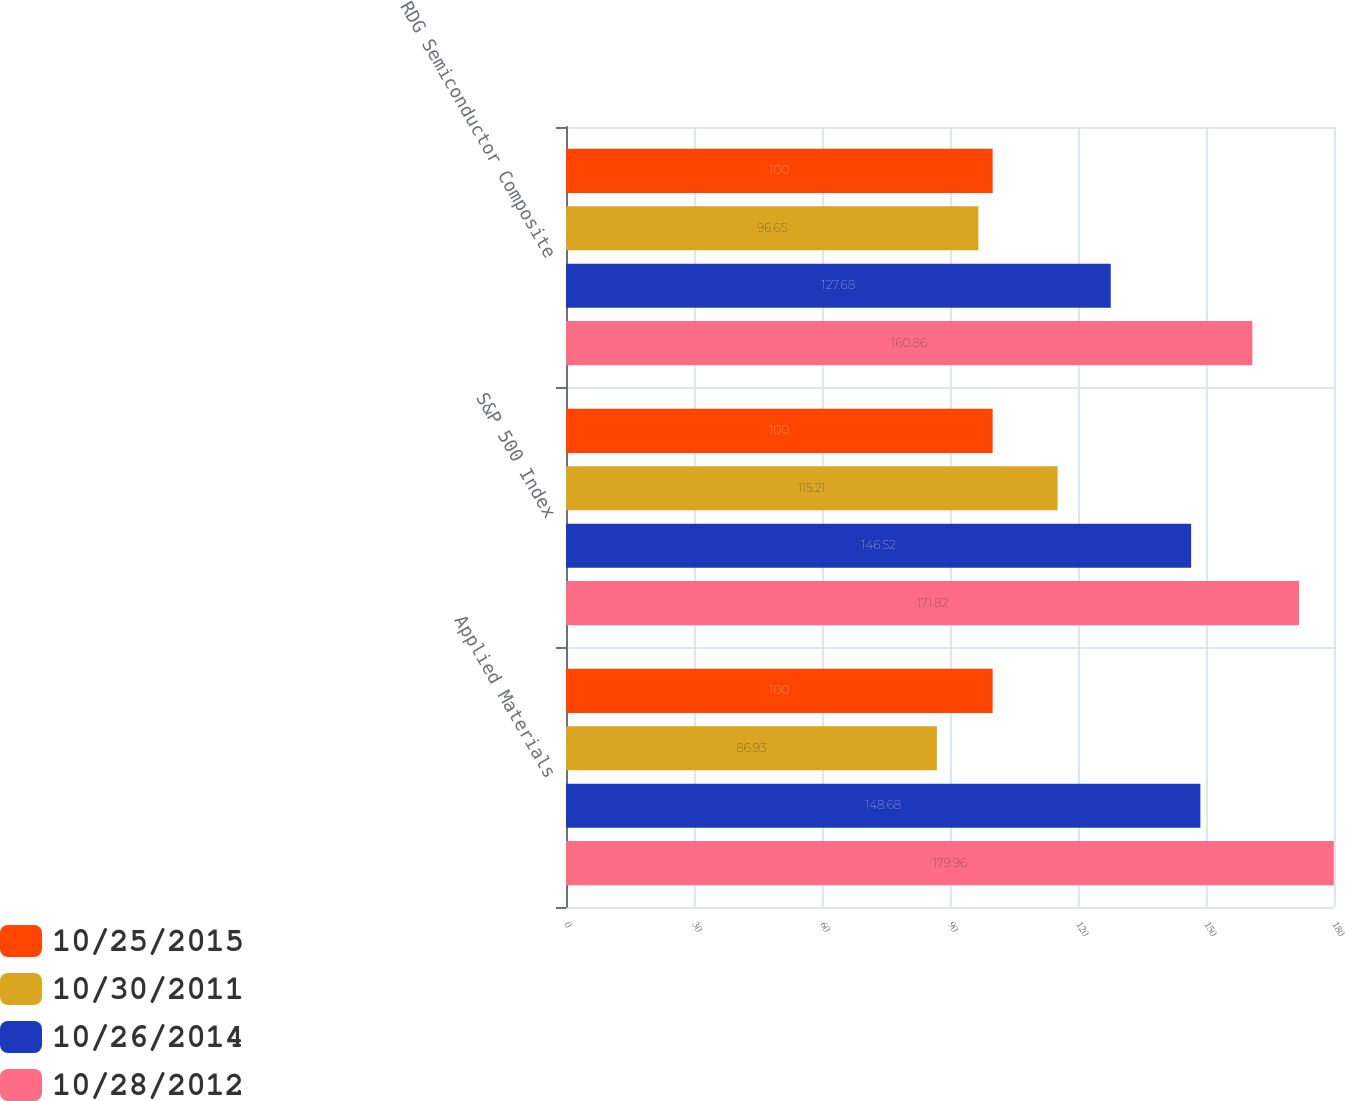Convert chart. <chart><loc_0><loc_0><loc_500><loc_500><stacked_bar_chart><ecel><fcel>Applied Materials<fcel>S&P 500 Index<fcel>RDG Semiconductor Composite<nl><fcel>10/25/2015<fcel>100<fcel>100<fcel>100<nl><fcel>10/30/2011<fcel>86.93<fcel>115.21<fcel>96.65<nl><fcel>10/26/2014<fcel>148.68<fcel>146.52<fcel>127.68<nl><fcel>10/28/2012<fcel>179.96<fcel>171.82<fcel>160.86<nl></chart> 